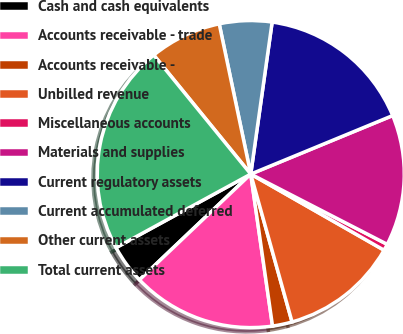Convert chart. <chart><loc_0><loc_0><loc_500><loc_500><pie_chart><fcel>Cash and cash equivalents<fcel>Accounts receivable - trade<fcel>Accounts receivable -<fcel>Unbilled revenue<fcel>Miscellaneous accounts<fcel>Materials and supplies<fcel>Current regulatory assets<fcel>Current accumulated deferred<fcel>Other current assets<fcel>Total current assets<nl><fcel>4.14%<fcel>15.17%<fcel>2.07%<fcel>12.41%<fcel>0.69%<fcel>13.79%<fcel>16.55%<fcel>5.52%<fcel>7.59%<fcel>22.07%<nl></chart> 